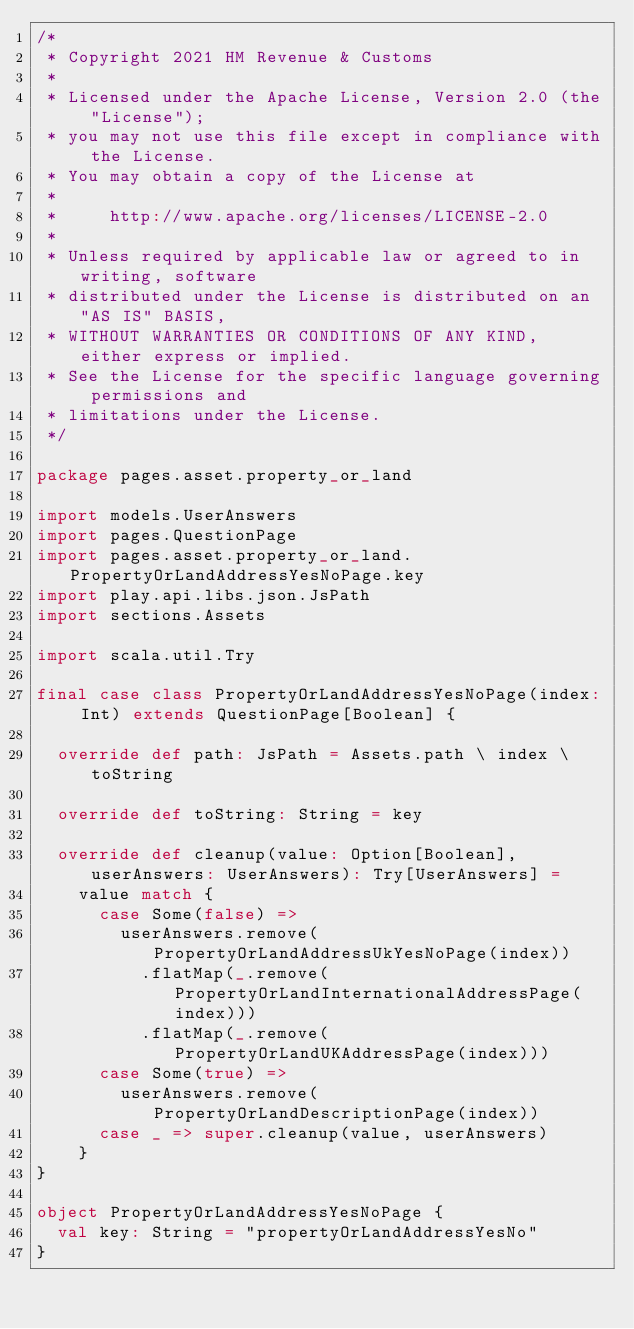<code> <loc_0><loc_0><loc_500><loc_500><_Scala_>/*
 * Copyright 2021 HM Revenue & Customs
 *
 * Licensed under the Apache License, Version 2.0 (the "License");
 * you may not use this file except in compliance with the License.
 * You may obtain a copy of the License at
 *
 *     http://www.apache.org/licenses/LICENSE-2.0
 *
 * Unless required by applicable law or agreed to in writing, software
 * distributed under the License is distributed on an "AS IS" BASIS,
 * WITHOUT WARRANTIES OR CONDITIONS OF ANY KIND, either express or implied.
 * See the License for the specific language governing permissions and
 * limitations under the License.
 */

package pages.asset.property_or_land

import models.UserAnswers
import pages.QuestionPage
import pages.asset.property_or_land.PropertyOrLandAddressYesNoPage.key
import play.api.libs.json.JsPath
import sections.Assets

import scala.util.Try

final case class PropertyOrLandAddressYesNoPage(index: Int) extends QuestionPage[Boolean] {

  override def path: JsPath = Assets.path \ index \ toString

  override def toString: String = key

  override def cleanup(value: Option[Boolean], userAnswers: UserAnswers): Try[UserAnswers] =
    value match {
      case Some(false) =>
        userAnswers.remove(PropertyOrLandAddressUkYesNoPage(index))
          .flatMap(_.remove(PropertyOrLandInternationalAddressPage(index)))
          .flatMap(_.remove(PropertyOrLandUKAddressPage(index)))
      case Some(true) =>
        userAnswers.remove(PropertyOrLandDescriptionPage(index))
      case _ => super.cleanup(value, userAnswers)
    }
}

object PropertyOrLandAddressYesNoPage {
  val key: String = "propertyOrLandAddressYesNo"
}
</code> 